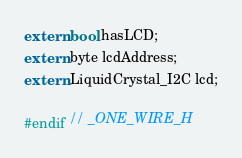Convert code to text. <code><loc_0><loc_0><loc_500><loc_500><_C_>
extern bool hasLCD;
extern byte lcdAddress;
extern LiquidCrystal_I2C lcd;

#endif // _ONE_WIRE_H
</code> 